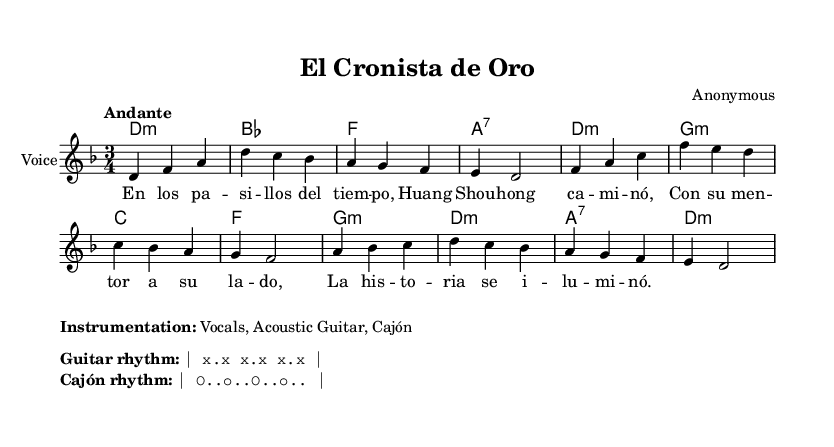What is the key signature of this music? The key signature is indicated at the beginning of the score and shows two flats, which assigns the piece to D minor.
Answer: D minor What is the tempo marking for this piece? The tempo marking is written in Italian above the staff, indicating how fast the music should be played. Here, it specifies "Andante," which suggests a moderate walking pace.
Answer: Andante What is the time signature of the piece? The time signature appears after the key signature and states that there are three beats per measure, notated as 3/4.
Answer: 3/4 How many lines does the melody have? Counting the vertical lines in the staff indicates the total number of musical phrases or measures. There are a total of eight measures in the melody section.
Answer: Eight What instruments are specified for this piece? The instrumentation details are noted in the markup section of the score, which lists the instruments intended for performance, making it clear that the piece is for Vocals, Acoustic Guitar, and Cajón.
Answer: Vocals, Acoustic Guitar, Cajón What type of musical form does this piece represent? By analyzing the structure of the melody and lyrics, and considering the typical forms found in Latin folk songs, this song is reflective of a strophic form where the same music is repeated for each verse.
Answer: Strophic 